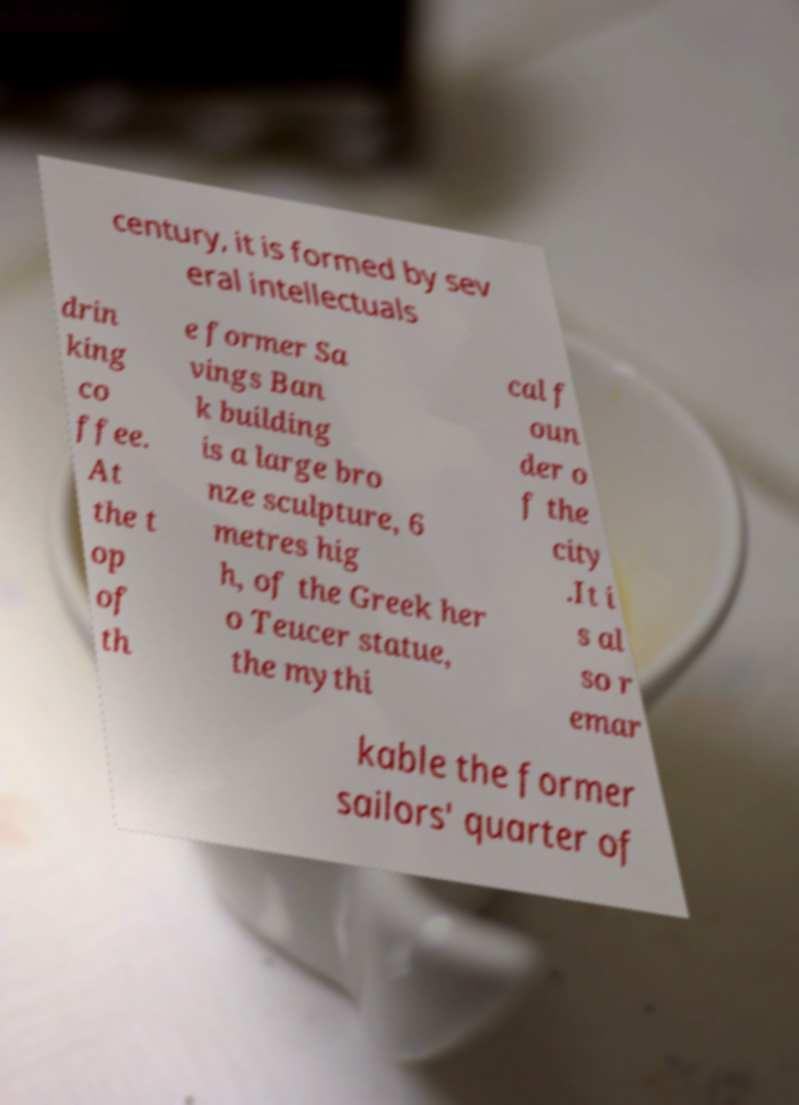Please read and relay the text visible in this image. What does it say? century, it is formed by sev eral intellectuals drin king co ffee. At the t op of th e former Sa vings Ban k building is a large bro nze sculpture, 6 metres hig h, of the Greek her o Teucer statue, the mythi cal f oun der o f the city .It i s al so r emar kable the former sailors' quarter of 